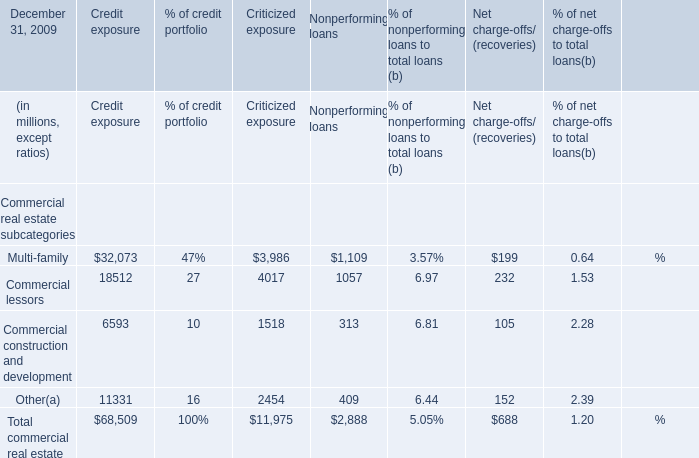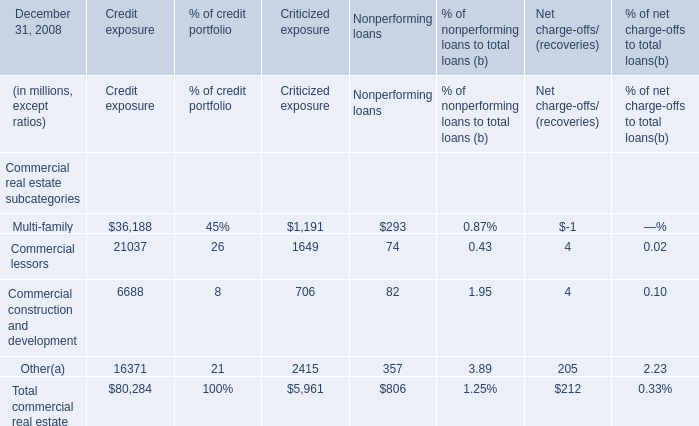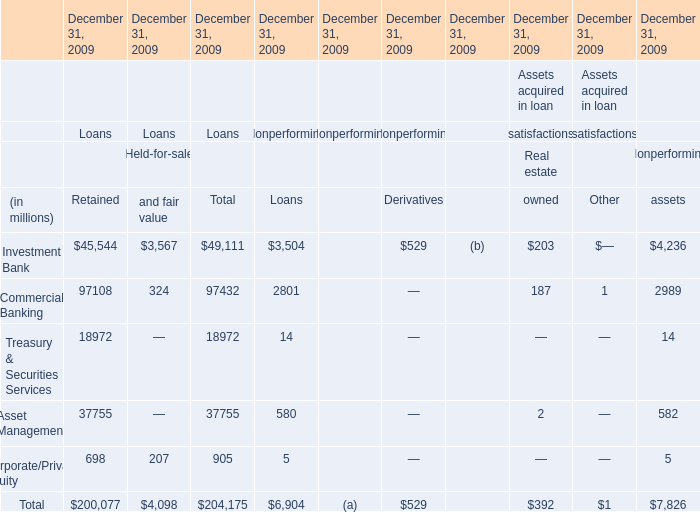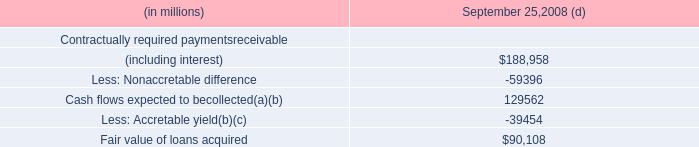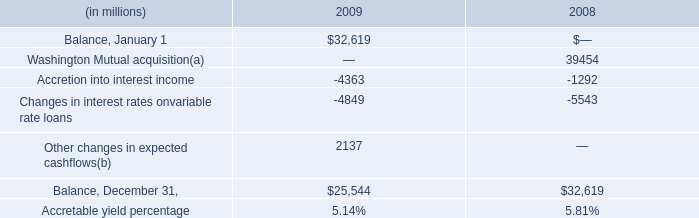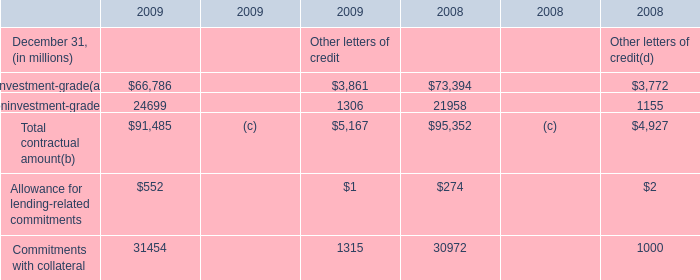In the section with the most Commercial lessors, what is the growth rate of Commercial construction and developmen? 
Answer: 8. 